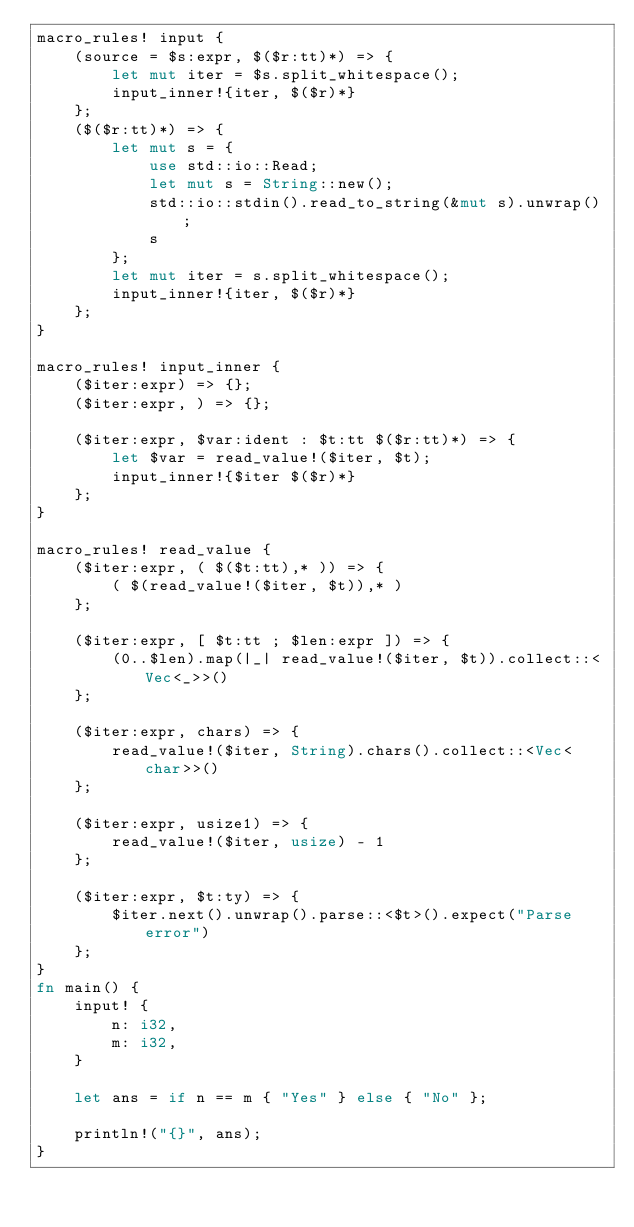<code> <loc_0><loc_0><loc_500><loc_500><_Rust_>macro_rules! input {
    (source = $s:expr, $($r:tt)*) => {
        let mut iter = $s.split_whitespace();
        input_inner!{iter, $($r)*}
    };
    ($($r:tt)*) => {
        let mut s = {
            use std::io::Read;
            let mut s = String::new();
            std::io::stdin().read_to_string(&mut s).unwrap();
            s
        };
        let mut iter = s.split_whitespace();
        input_inner!{iter, $($r)*}
    };
}

macro_rules! input_inner {
    ($iter:expr) => {};
    ($iter:expr, ) => {};

    ($iter:expr, $var:ident : $t:tt $($r:tt)*) => {
        let $var = read_value!($iter, $t);
        input_inner!{$iter $($r)*}
    };
}

macro_rules! read_value {
    ($iter:expr, ( $($t:tt),* )) => {
        ( $(read_value!($iter, $t)),* )
    };

    ($iter:expr, [ $t:tt ; $len:expr ]) => {
        (0..$len).map(|_| read_value!($iter, $t)).collect::<Vec<_>>()
    };

    ($iter:expr, chars) => {
        read_value!($iter, String).chars().collect::<Vec<char>>()
    };

    ($iter:expr, usize1) => {
        read_value!($iter, usize) - 1
    };

    ($iter:expr, $t:ty) => {
        $iter.next().unwrap().parse::<$t>().expect("Parse error")
    };
}
fn main() {
    input! {
        n: i32,
        m: i32,
    }

    let ans = if n == m { "Yes" } else { "No" };

    println!("{}", ans);
}
</code> 